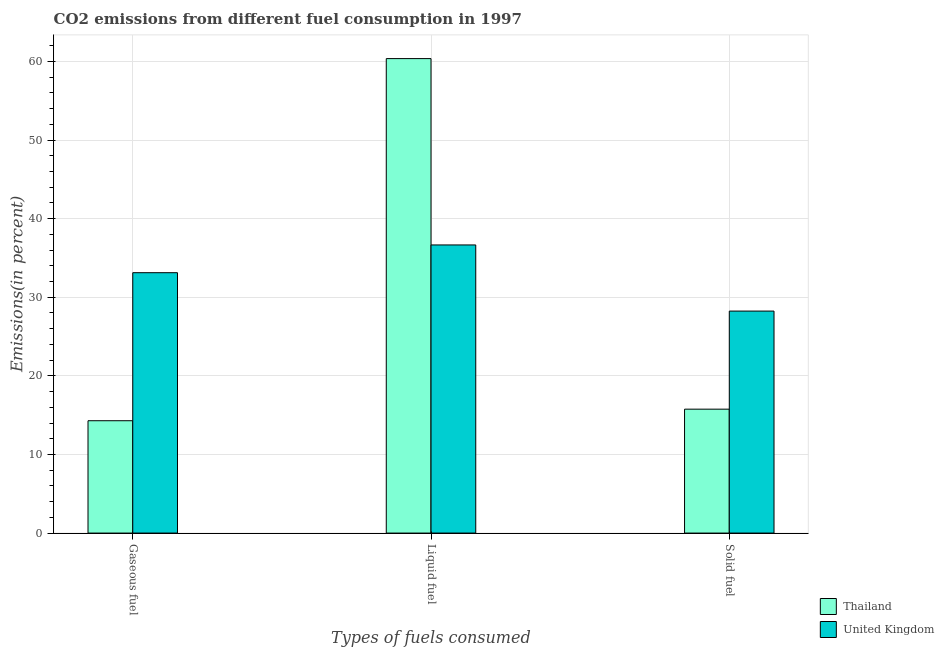How many different coloured bars are there?
Your answer should be compact. 2. Are the number of bars per tick equal to the number of legend labels?
Make the answer very short. Yes. Are the number of bars on each tick of the X-axis equal?
Your answer should be very brief. Yes. How many bars are there on the 3rd tick from the left?
Your response must be concise. 2. How many bars are there on the 2nd tick from the right?
Provide a short and direct response. 2. What is the label of the 3rd group of bars from the left?
Your answer should be compact. Solid fuel. What is the percentage of liquid fuel emission in Thailand?
Offer a very short reply. 60.36. Across all countries, what is the maximum percentage of gaseous fuel emission?
Your response must be concise. 33.12. Across all countries, what is the minimum percentage of gaseous fuel emission?
Provide a short and direct response. 14.29. In which country was the percentage of liquid fuel emission maximum?
Keep it short and to the point. Thailand. In which country was the percentage of solid fuel emission minimum?
Ensure brevity in your answer.  Thailand. What is the total percentage of gaseous fuel emission in the graph?
Your answer should be very brief. 47.42. What is the difference between the percentage of solid fuel emission in United Kingdom and that in Thailand?
Your answer should be very brief. 12.48. What is the difference between the percentage of solid fuel emission in Thailand and the percentage of gaseous fuel emission in United Kingdom?
Provide a short and direct response. -17.36. What is the average percentage of gaseous fuel emission per country?
Your answer should be very brief. 23.71. What is the difference between the percentage of gaseous fuel emission and percentage of liquid fuel emission in United Kingdom?
Your response must be concise. -3.53. In how many countries, is the percentage of solid fuel emission greater than 6 %?
Your response must be concise. 2. What is the ratio of the percentage of liquid fuel emission in United Kingdom to that in Thailand?
Your response must be concise. 0.61. Is the percentage of gaseous fuel emission in United Kingdom less than that in Thailand?
Offer a terse response. No. What is the difference between the highest and the second highest percentage of liquid fuel emission?
Provide a short and direct response. 23.71. What is the difference between the highest and the lowest percentage of solid fuel emission?
Your answer should be compact. 12.48. What does the 2nd bar from the left in Solid fuel represents?
Offer a terse response. United Kingdom. What does the 2nd bar from the right in Liquid fuel represents?
Make the answer very short. Thailand. Is it the case that in every country, the sum of the percentage of gaseous fuel emission and percentage of liquid fuel emission is greater than the percentage of solid fuel emission?
Make the answer very short. Yes. How many bars are there?
Provide a short and direct response. 6. What is the difference between two consecutive major ticks on the Y-axis?
Keep it short and to the point. 10. Does the graph contain any zero values?
Your response must be concise. No. How many legend labels are there?
Make the answer very short. 2. What is the title of the graph?
Offer a terse response. CO2 emissions from different fuel consumption in 1997. What is the label or title of the X-axis?
Provide a short and direct response. Types of fuels consumed. What is the label or title of the Y-axis?
Provide a succinct answer. Emissions(in percent). What is the Emissions(in percent) in Thailand in Gaseous fuel?
Ensure brevity in your answer.  14.29. What is the Emissions(in percent) of United Kingdom in Gaseous fuel?
Provide a succinct answer. 33.12. What is the Emissions(in percent) of Thailand in Liquid fuel?
Offer a terse response. 60.36. What is the Emissions(in percent) in United Kingdom in Liquid fuel?
Keep it short and to the point. 36.65. What is the Emissions(in percent) in Thailand in Solid fuel?
Offer a terse response. 15.76. What is the Emissions(in percent) of United Kingdom in Solid fuel?
Offer a very short reply. 28.24. Across all Types of fuels consumed, what is the maximum Emissions(in percent) of Thailand?
Offer a terse response. 60.36. Across all Types of fuels consumed, what is the maximum Emissions(in percent) of United Kingdom?
Keep it short and to the point. 36.65. Across all Types of fuels consumed, what is the minimum Emissions(in percent) of Thailand?
Give a very brief answer. 14.29. Across all Types of fuels consumed, what is the minimum Emissions(in percent) of United Kingdom?
Your answer should be compact. 28.24. What is the total Emissions(in percent) in Thailand in the graph?
Provide a short and direct response. 90.41. What is the total Emissions(in percent) of United Kingdom in the graph?
Ensure brevity in your answer.  98.01. What is the difference between the Emissions(in percent) of Thailand in Gaseous fuel and that in Liquid fuel?
Provide a succinct answer. -46.07. What is the difference between the Emissions(in percent) in United Kingdom in Gaseous fuel and that in Liquid fuel?
Provide a short and direct response. -3.53. What is the difference between the Emissions(in percent) in Thailand in Gaseous fuel and that in Solid fuel?
Offer a terse response. -1.47. What is the difference between the Emissions(in percent) of United Kingdom in Gaseous fuel and that in Solid fuel?
Keep it short and to the point. 4.88. What is the difference between the Emissions(in percent) of Thailand in Liquid fuel and that in Solid fuel?
Offer a very short reply. 44.6. What is the difference between the Emissions(in percent) in United Kingdom in Liquid fuel and that in Solid fuel?
Give a very brief answer. 8.41. What is the difference between the Emissions(in percent) in Thailand in Gaseous fuel and the Emissions(in percent) in United Kingdom in Liquid fuel?
Keep it short and to the point. -22.36. What is the difference between the Emissions(in percent) of Thailand in Gaseous fuel and the Emissions(in percent) of United Kingdom in Solid fuel?
Give a very brief answer. -13.95. What is the difference between the Emissions(in percent) in Thailand in Liquid fuel and the Emissions(in percent) in United Kingdom in Solid fuel?
Offer a terse response. 32.12. What is the average Emissions(in percent) in Thailand per Types of fuels consumed?
Provide a short and direct response. 30.14. What is the average Emissions(in percent) in United Kingdom per Types of fuels consumed?
Keep it short and to the point. 32.67. What is the difference between the Emissions(in percent) in Thailand and Emissions(in percent) in United Kingdom in Gaseous fuel?
Offer a very short reply. -18.83. What is the difference between the Emissions(in percent) of Thailand and Emissions(in percent) of United Kingdom in Liquid fuel?
Your response must be concise. 23.71. What is the difference between the Emissions(in percent) in Thailand and Emissions(in percent) in United Kingdom in Solid fuel?
Provide a short and direct response. -12.48. What is the ratio of the Emissions(in percent) in Thailand in Gaseous fuel to that in Liquid fuel?
Provide a succinct answer. 0.24. What is the ratio of the Emissions(in percent) of United Kingdom in Gaseous fuel to that in Liquid fuel?
Your answer should be compact. 0.9. What is the ratio of the Emissions(in percent) of Thailand in Gaseous fuel to that in Solid fuel?
Provide a succinct answer. 0.91. What is the ratio of the Emissions(in percent) of United Kingdom in Gaseous fuel to that in Solid fuel?
Provide a succinct answer. 1.17. What is the ratio of the Emissions(in percent) in Thailand in Liquid fuel to that in Solid fuel?
Offer a terse response. 3.83. What is the ratio of the Emissions(in percent) in United Kingdom in Liquid fuel to that in Solid fuel?
Ensure brevity in your answer.  1.3. What is the difference between the highest and the second highest Emissions(in percent) of Thailand?
Keep it short and to the point. 44.6. What is the difference between the highest and the second highest Emissions(in percent) of United Kingdom?
Ensure brevity in your answer.  3.53. What is the difference between the highest and the lowest Emissions(in percent) in Thailand?
Offer a very short reply. 46.07. What is the difference between the highest and the lowest Emissions(in percent) of United Kingdom?
Make the answer very short. 8.41. 